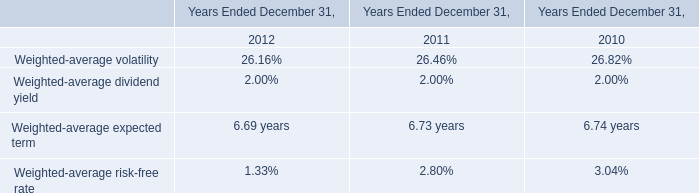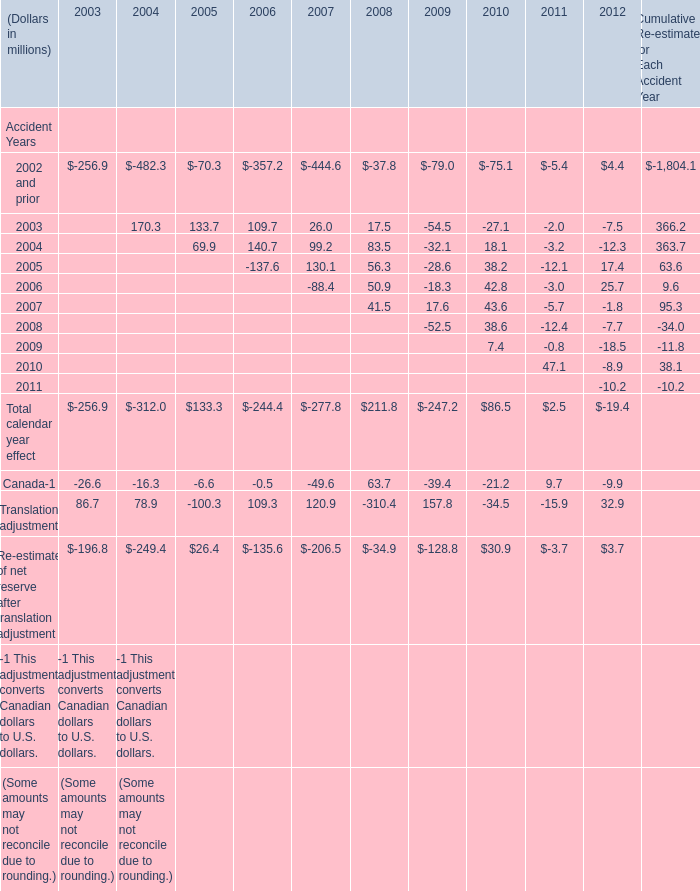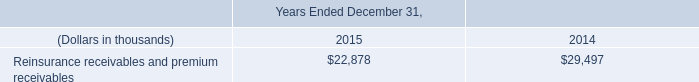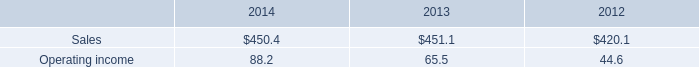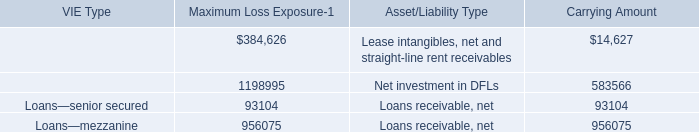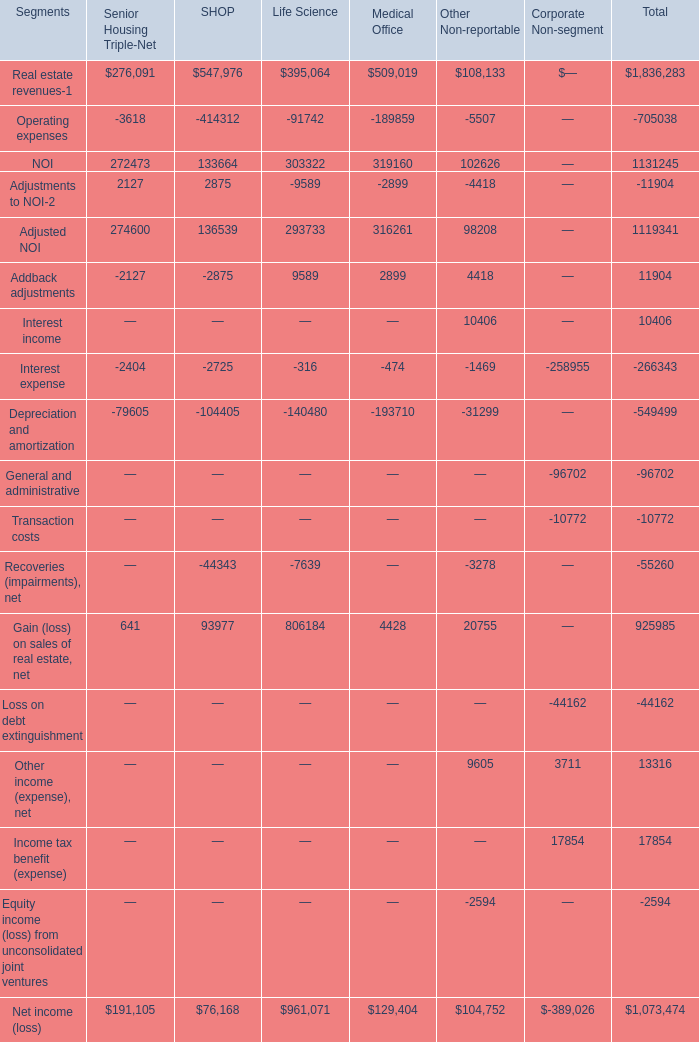What is the value of the Gain (loss) on sales of real estate, net for Life Science? 
Answer: 806184. 